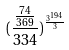Convert formula to latex. <formula><loc_0><loc_0><loc_500><loc_500>( \frac { \frac { 7 4 } { 3 6 9 } } { 3 3 4 } ) ^ { \frac { 3 ^ { 1 9 4 } } { 3 } }</formula> 